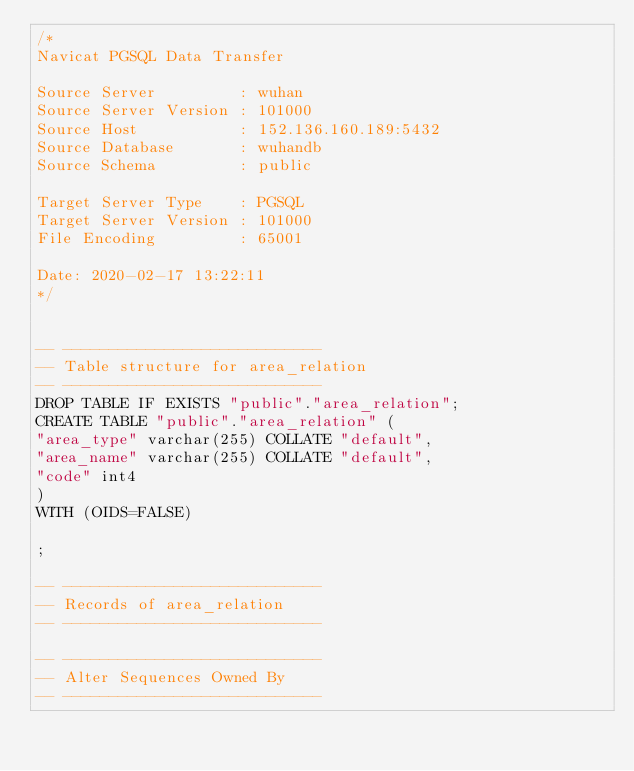Convert code to text. <code><loc_0><loc_0><loc_500><loc_500><_SQL_>/*
Navicat PGSQL Data Transfer

Source Server         : wuhan
Source Server Version : 101000
Source Host           : 152.136.160.189:5432
Source Database       : wuhandb
Source Schema         : public

Target Server Type    : PGSQL
Target Server Version : 101000
File Encoding         : 65001

Date: 2020-02-17 13:22:11
*/


-- ----------------------------
-- Table structure for area_relation
-- ----------------------------
DROP TABLE IF EXISTS "public"."area_relation";
CREATE TABLE "public"."area_relation" (
"area_type" varchar(255) COLLATE "default",
"area_name" varchar(255) COLLATE "default",
"code" int4
)
WITH (OIDS=FALSE)

;

-- ----------------------------
-- Records of area_relation
-- ----------------------------

-- ----------------------------
-- Alter Sequences Owned By 
-- ----------------------------
</code> 